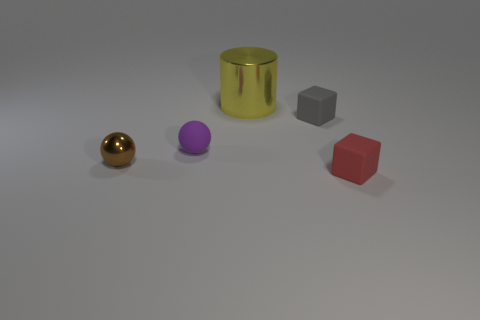There is another purple sphere that is the same size as the metal sphere; what is it made of?
Offer a very short reply. Rubber. Do the block left of the red object and the small object that is in front of the small brown metallic sphere have the same material?
Give a very brief answer. Yes. What is the shape of the red object that is the same size as the brown metal thing?
Offer a terse response. Cube. How many other things are the same color as the matte ball?
Your answer should be very brief. 0. What color is the tiny rubber object that is in front of the shiny ball?
Provide a short and direct response. Red. What number of other things are there of the same material as the gray block
Your response must be concise. 2. Is the number of gray matte objects that are to the left of the yellow cylinder greater than the number of purple matte balls that are to the left of the shiny sphere?
Keep it short and to the point. No. What number of small objects are in front of the brown thing?
Your answer should be compact. 1. Does the red cube have the same material as the small cube that is behind the small red cube?
Your answer should be compact. Yes. Is there anything else that has the same shape as the purple thing?
Give a very brief answer. Yes. 